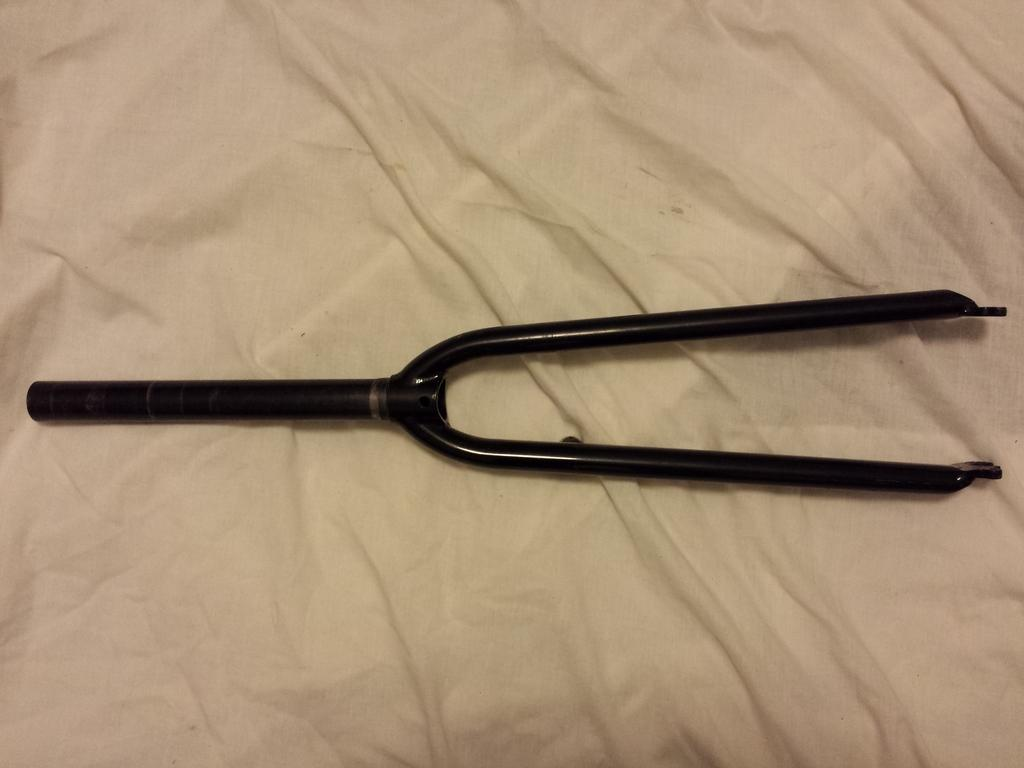What can be seen in the image? There is an object in the image. What is at the bottom of the image? There is a white cloth at the bottom of the image. What type of mint is being served in the lunchroom in the image? There is no mention of mint or a lunchroom in the image, so we cannot answer this question. 